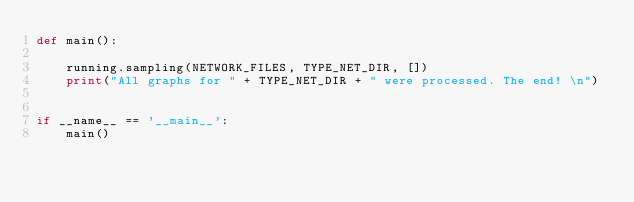Convert code to text. <code><loc_0><loc_0><loc_500><loc_500><_Python_>def main():

    running.sampling(NETWORK_FILES, TYPE_NET_DIR, [])
    print("All graphs for " + TYPE_NET_DIR + " were processed. The end! \n")


if __name__ == '__main__':
    main()
</code> 